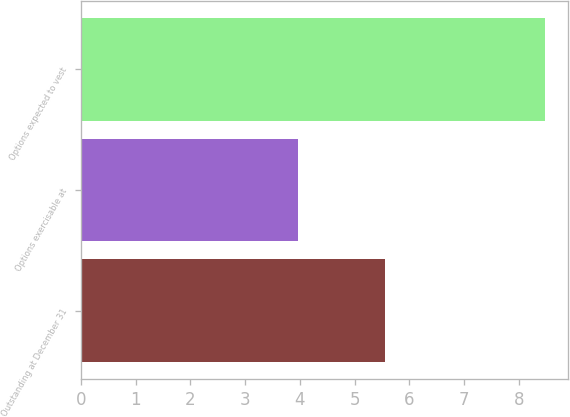<chart> <loc_0><loc_0><loc_500><loc_500><bar_chart><fcel>Outstanding at December 31<fcel>Options exercisable at<fcel>Options expected to vest<nl><fcel>5.56<fcel>3.96<fcel>8.48<nl></chart> 